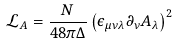<formula> <loc_0><loc_0><loc_500><loc_500>\mathcal { L } _ { A } = \frac { N } { 4 8 \pi \Delta } \left ( \epsilon _ { \mu \nu \lambda } \partial _ { \nu } A _ { \lambda } \right ) ^ { 2 }</formula> 